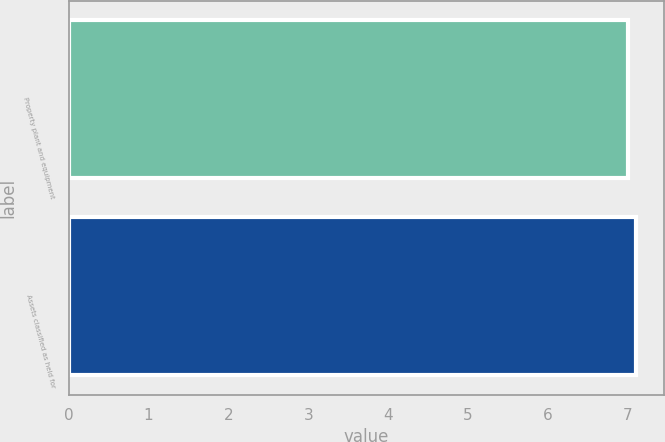Convert chart to OTSL. <chart><loc_0><loc_0><loc_500><loc_500><bar_chart><fcel>Property plant and equipment<fcel>Assets classified as held for<nl><fcel>7<fcel>7.1<nl></chart> 